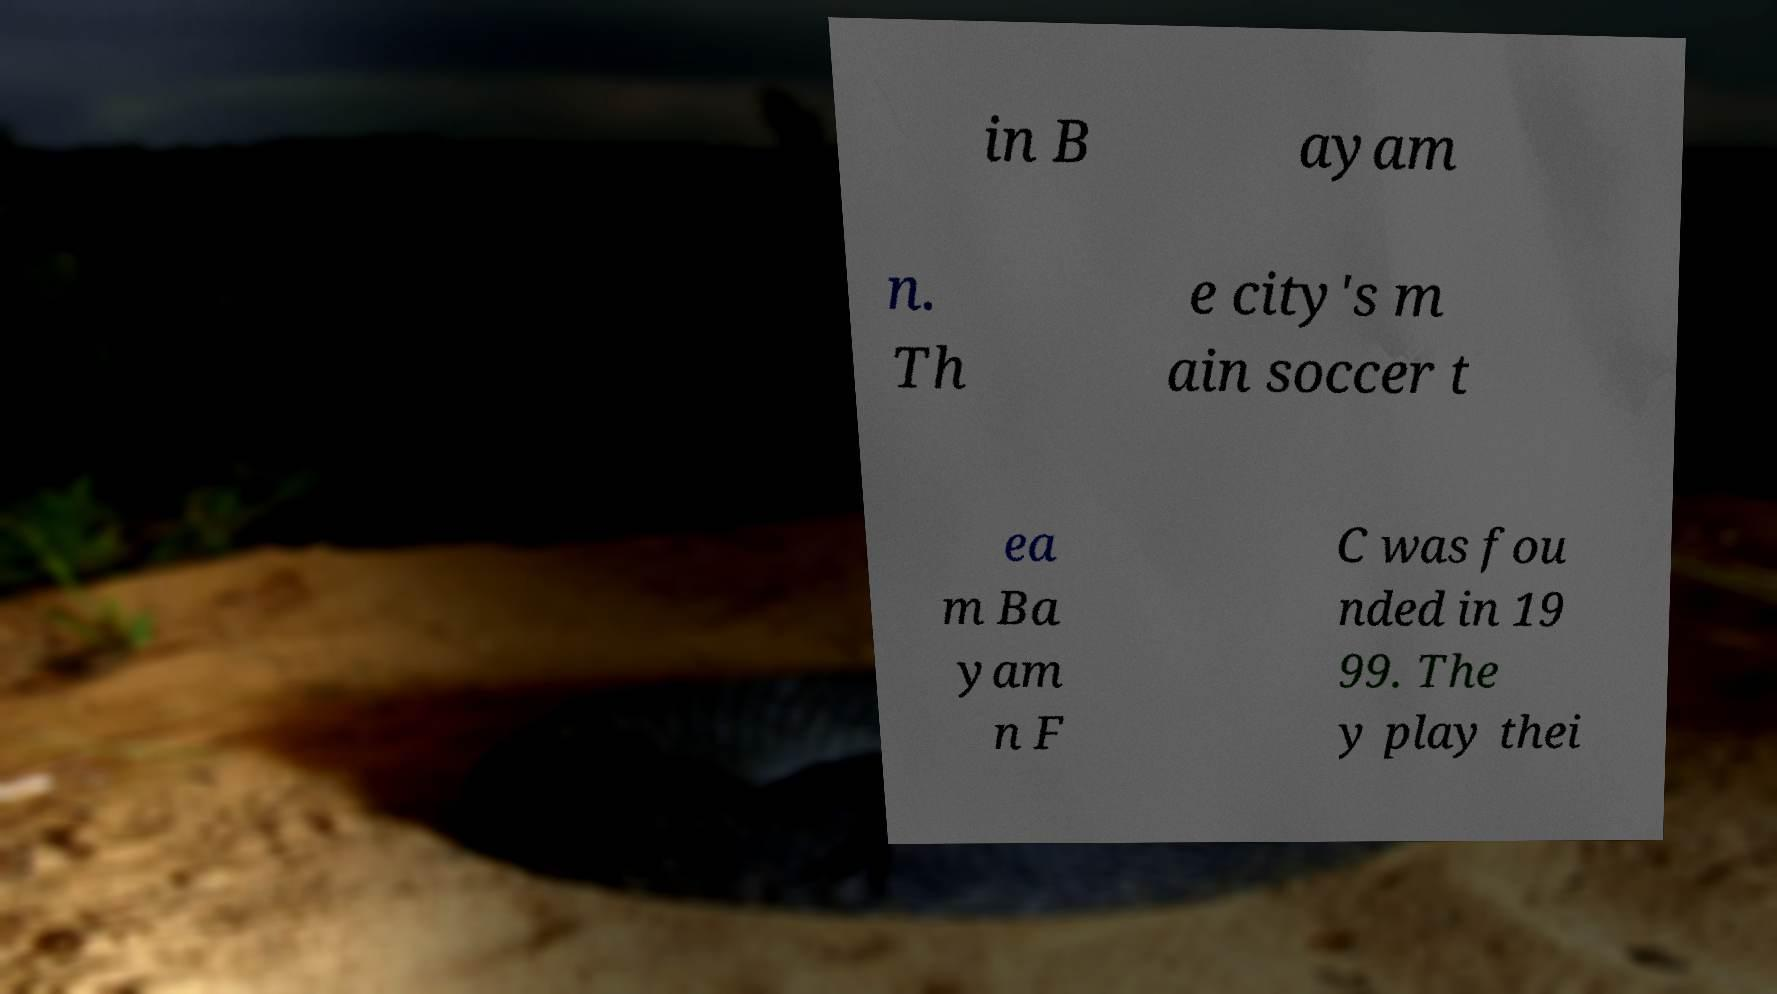Could you extract and type out the text from this image? in B ayam n. Th e city's m ain soccer t ea m Ba yam n F C was fou nded in 19 99. The y play thei 